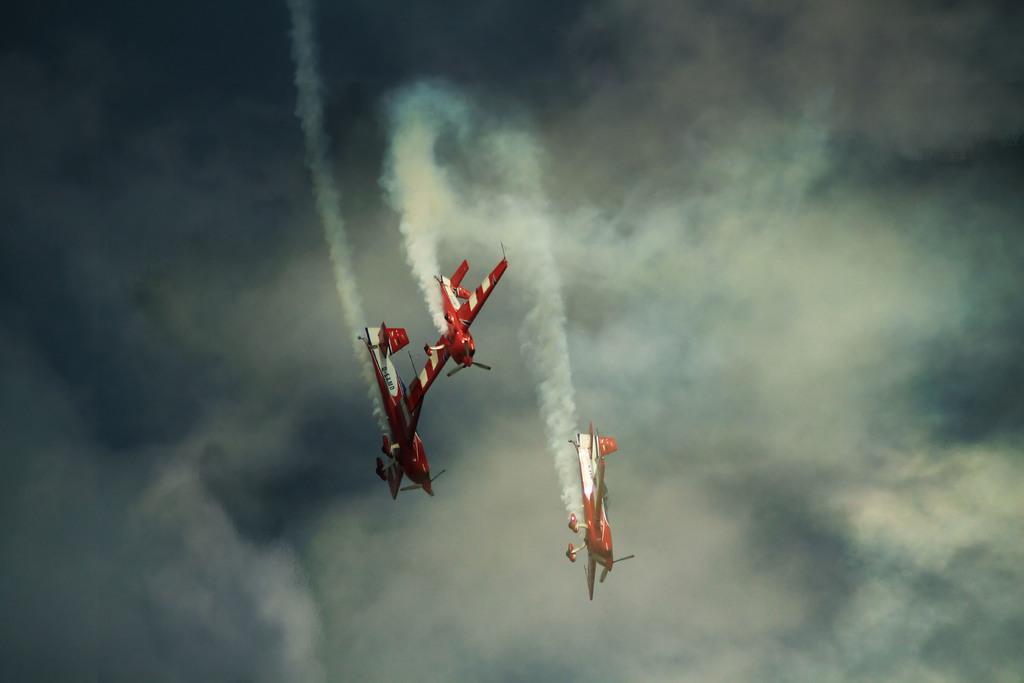Could you give a brief overview of what you see in this image? There are three red color aircraft flying in the air. And they are emitting smoke. In the background, there are clouds in the sky. 